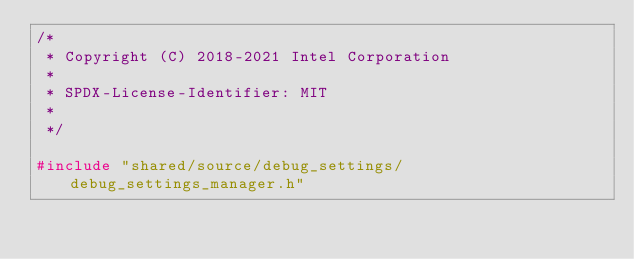<code> <loc_0><loc_0><loc_500><loc_500><_C++_>/*
 * Copyright (C) 2018-2021 Intel Corporation
 *
 * SPDX-License-Identifier: MIT
 *
 */

#include "shared/source/debug_settings/debug_settings_manager.h"</code> 